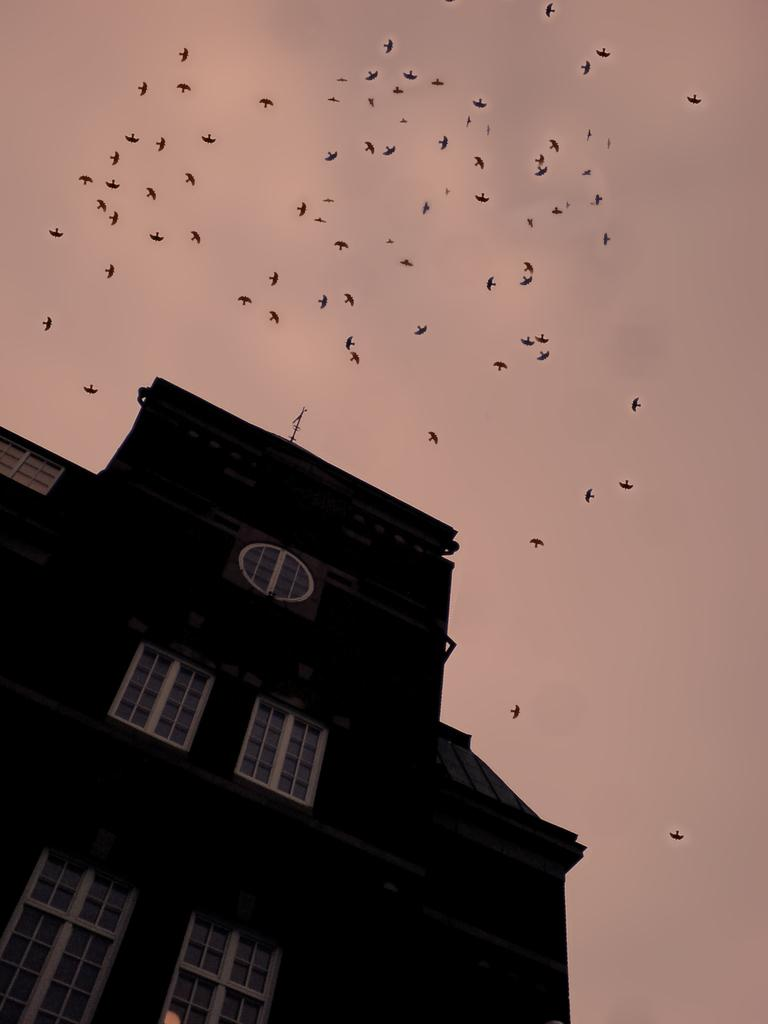What type of structure is in the picture? There is a building in the picture. What is the color of the building? The building is black in color. What feature can be seen on the building? The building has windows. What is happening in the sky in the picture? There are birds flying in the sky in the picture. What else can be seen in the sky? The sky is visible in the picture. What type of jam is being spread on the building in the picture? There is no jam present in the image, nor is any jam being spread on the building. 